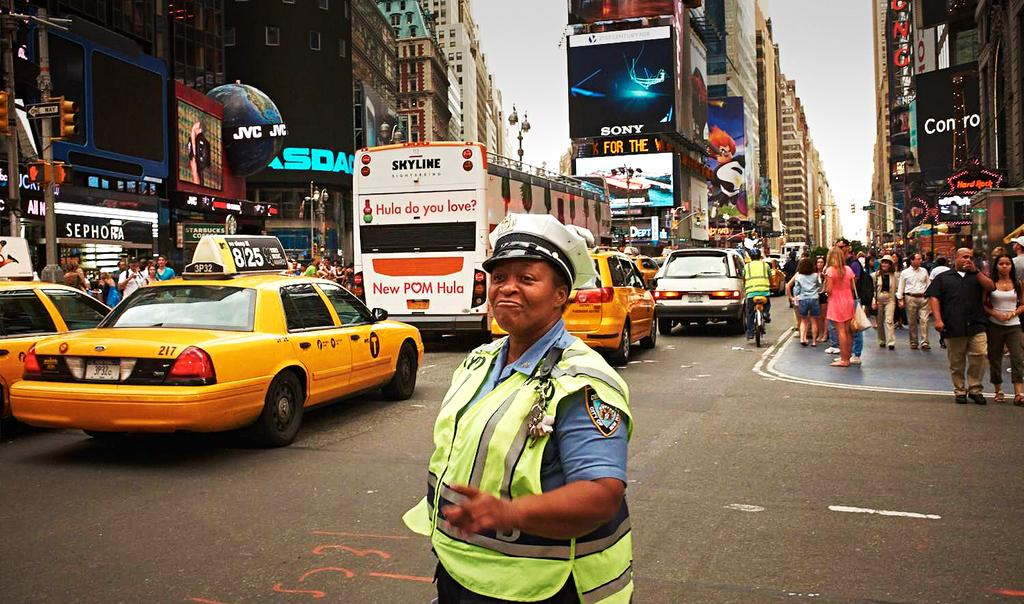<image>
Offer a succinct explanation of the picture presented. A police officer in a yellow vest is directing traffic at a busy downtown intersection under a sign that says Sony. 